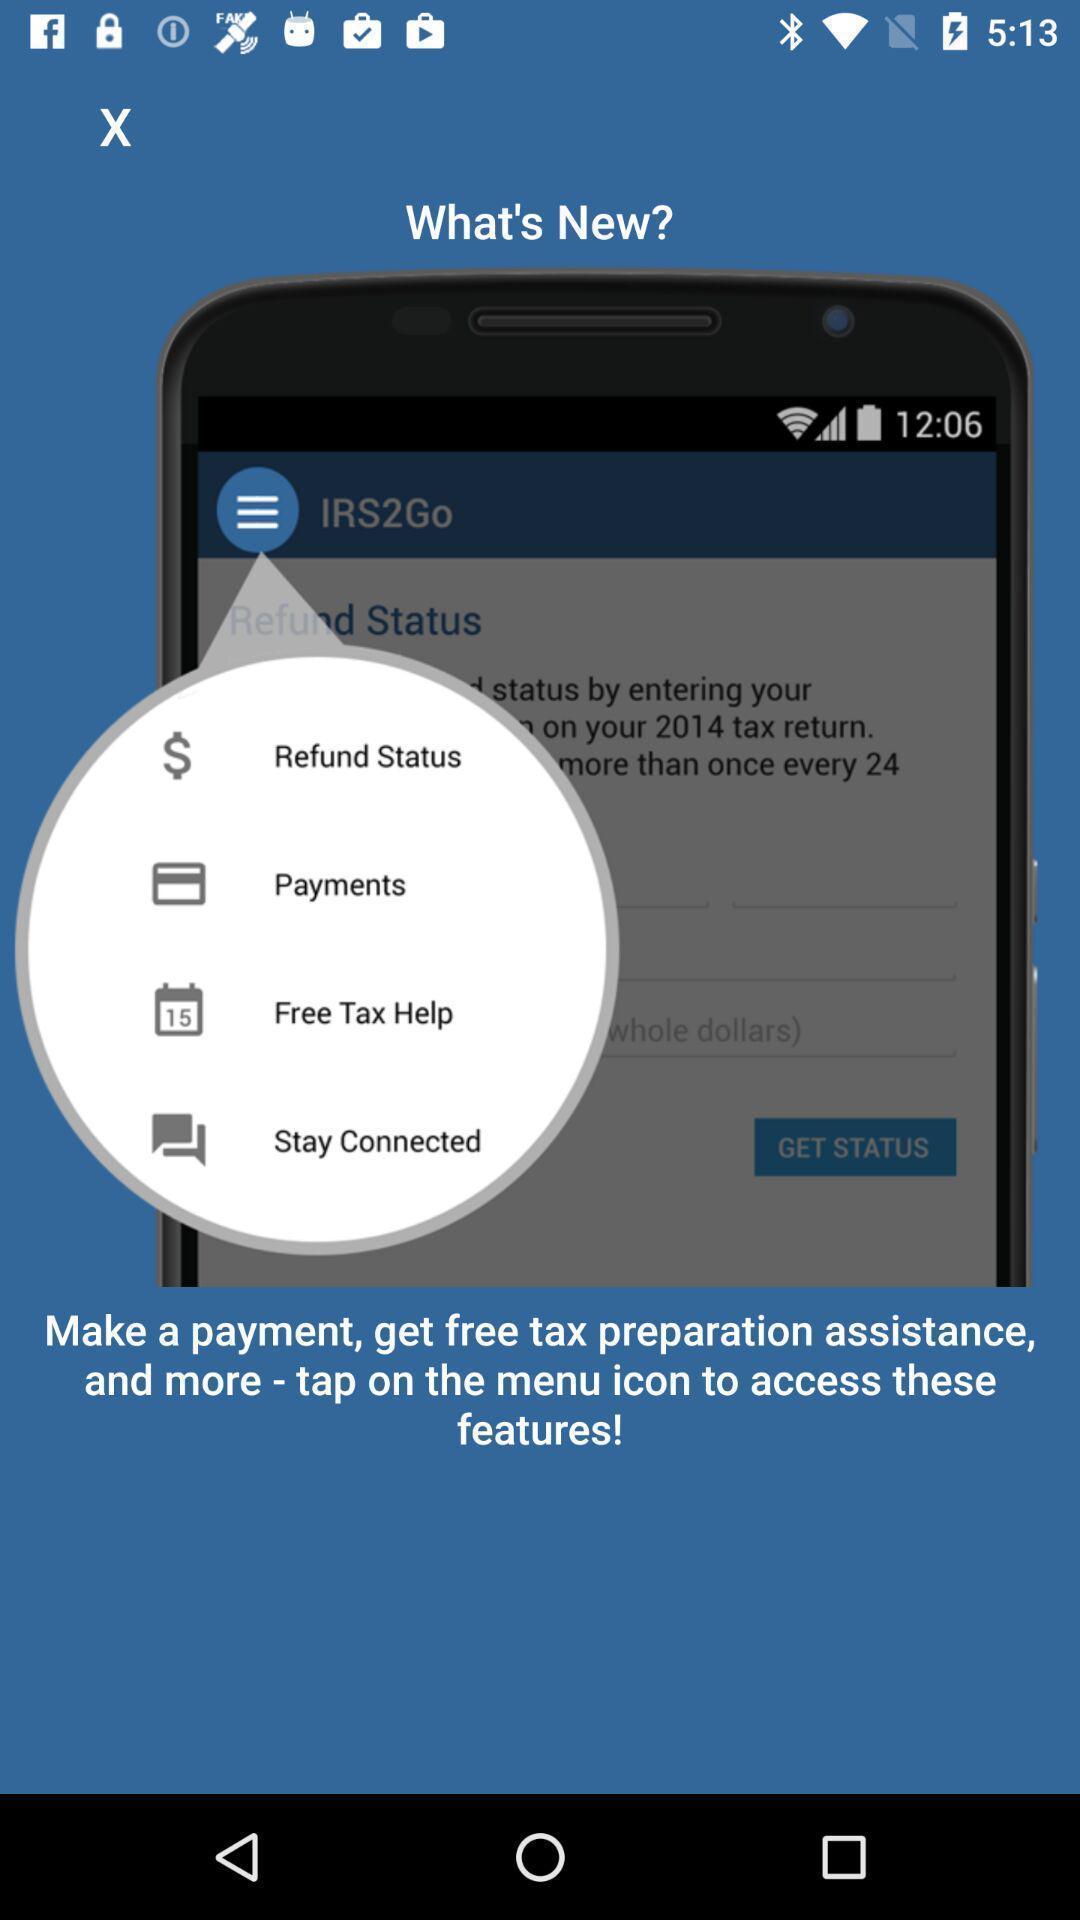Describe the key features of this screenshot. Screen displaying its key features before getting started. 